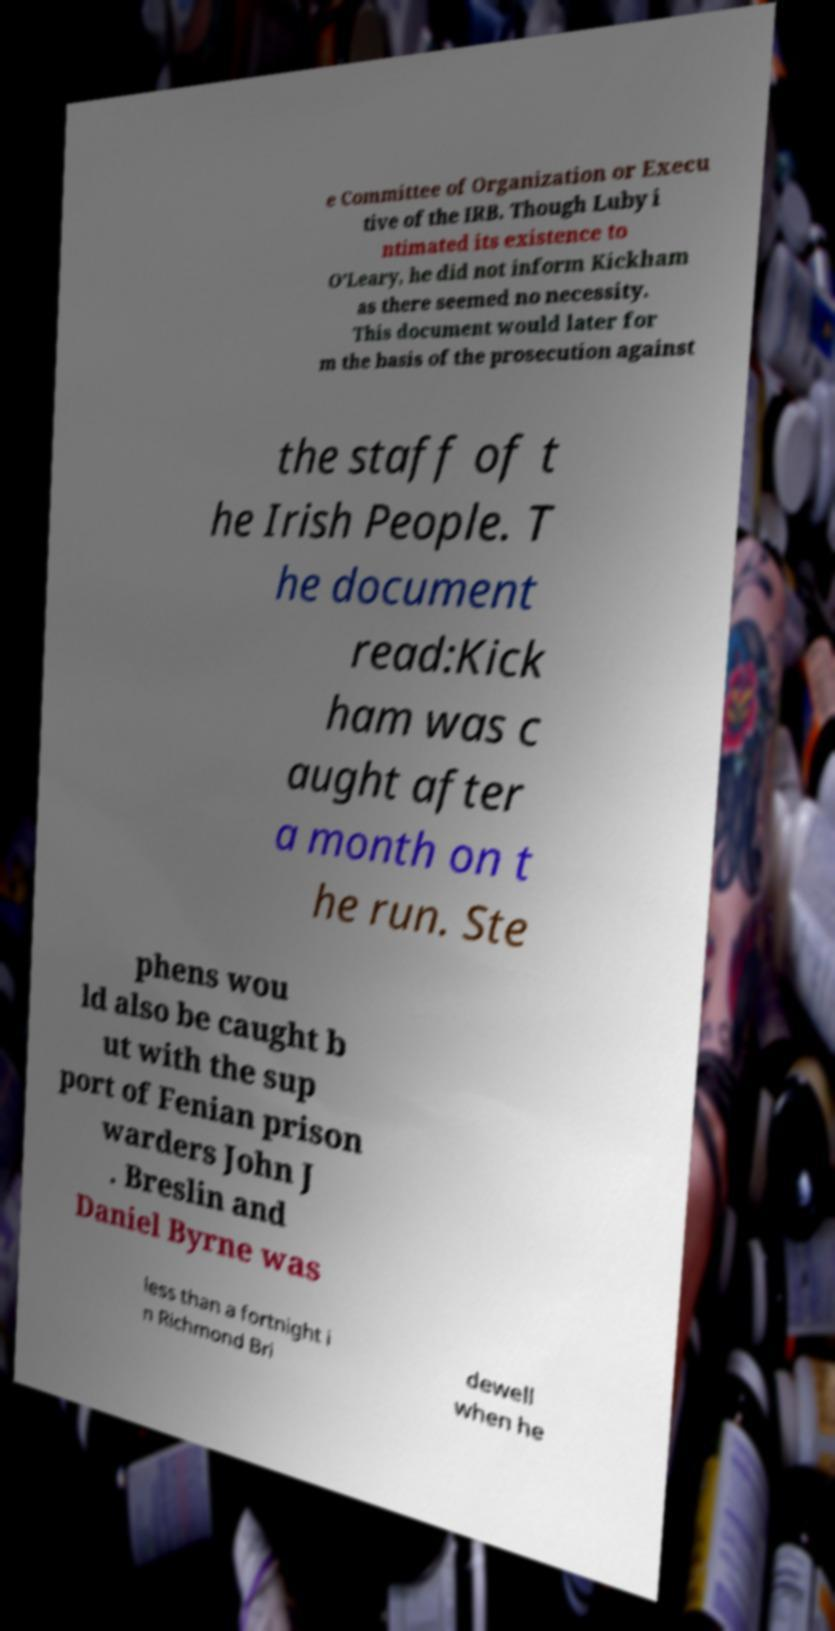Please read and relay the text visible in this image. What does it say? e Committee of Organization or Execu tive of the IRB. Though Luby i ntimated its existence to O’Leary, he did not inform Kickham as there seemed no necessity. This document would later for m the basis of the prosecution against the staff of t he Irish People. T he document read:Kick ham was c aught after a month on t he run. Ste phens wou ld also be caught b ut with the sup port of Fenian prison warders John J . Breslin and Daniel Byrne was less than a fortnight i n Richmond Bri dewell when he 